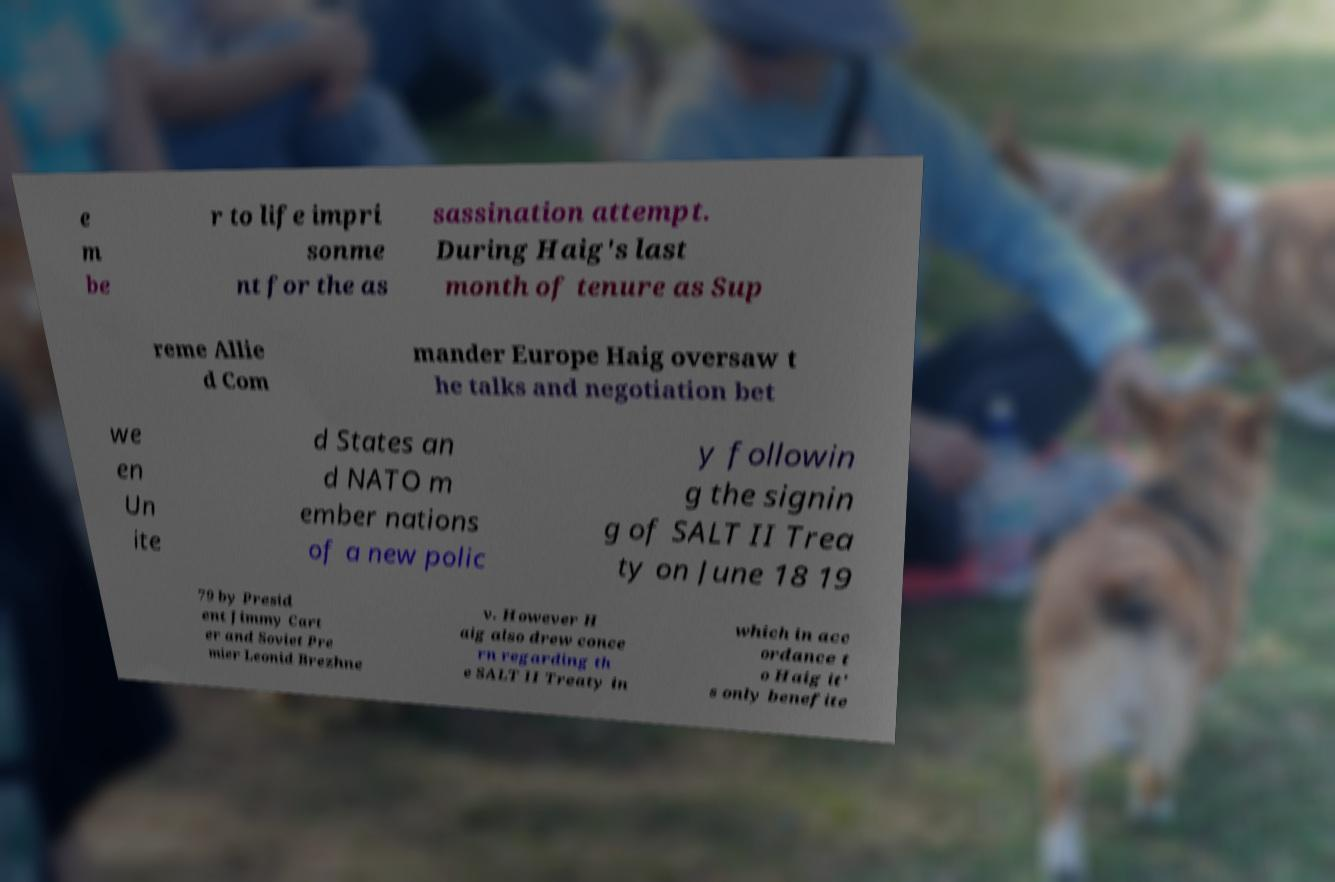Can you read and provide the text displayed in the image?This photo seems to have some interesting text. Can you extract and type it out for me? e m be r to life impri sonme nt for the as sassination attempt. During Haig's last month of tenure as Sup reme Allie d Com mander Europe Haig oversaw t he talks and negotiation bet we en Un ite d States an d NATO m ember nations of a new polic y followin g the signin g of SALT II Trea ty on June 18 19 79 by Presid ent Jimmy Cart er and Soviet Pre mier Leonid Brezhne v. However H aig also drew conce rn regarding th e SALT II Treaty in which in acc ordance t o Haig it' s only benefite 